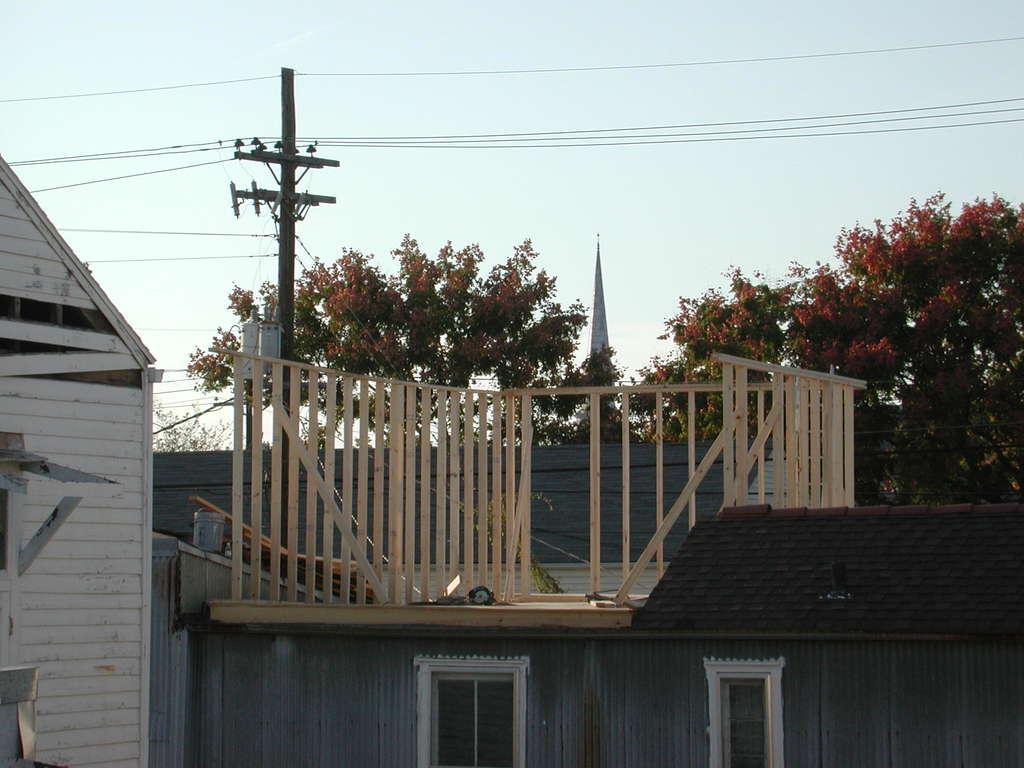In one or two sentences, can you explain what this image depicts? In this image we can see some houses with windows, there is an electrical pole with wires, in the background we can see some trees and the sky. 